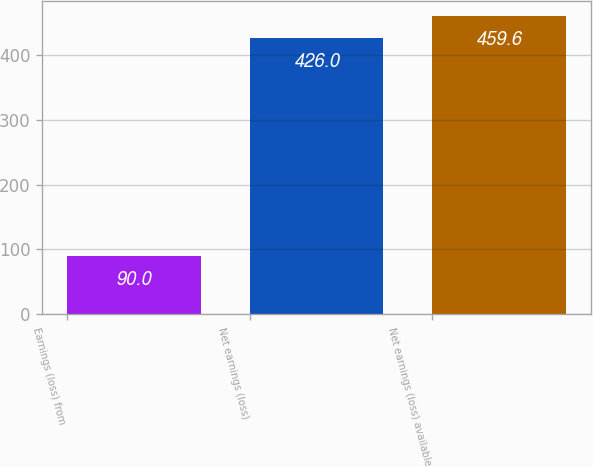<chart> <loc_0><loc_0><loc_500><loc_500><bar_chart><fcel>Earnings (loss) from<fcel>Net earnings (loss)<fcel>Net earnings (loss) available<nl><fcel>90<fcel>426<fcel>459.6<nl></chart> 